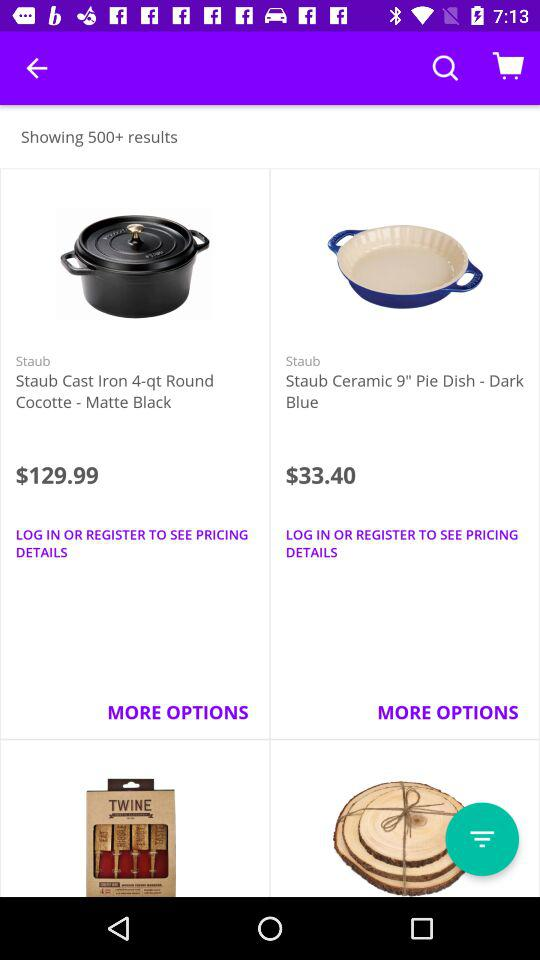How many results have been found? The number of results that have been found is more than 500. 